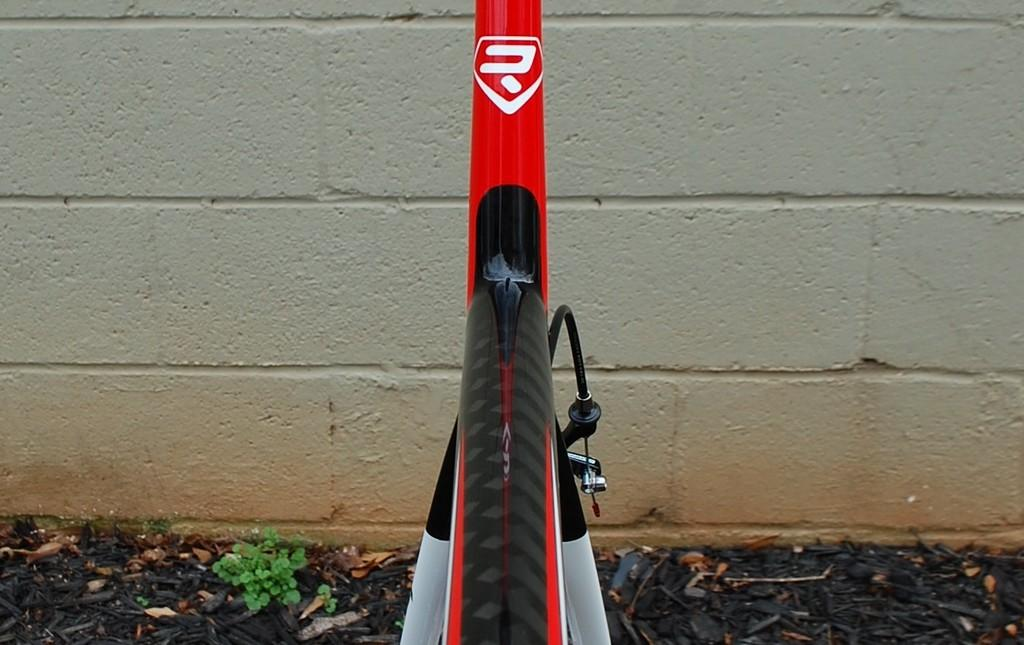What object is on the ground in the image? There is a bicycle on the ground in the image. What type of vegetation is on the left side of the image? There is a plant on the left side of the image. What can be seen in the background of the image? There is a wall in the background of the image. Where is the rabbit hiding in the image? There is no rabbit present in the image. What type of battle is taking place in the image? There is no battle depicted in the image. 